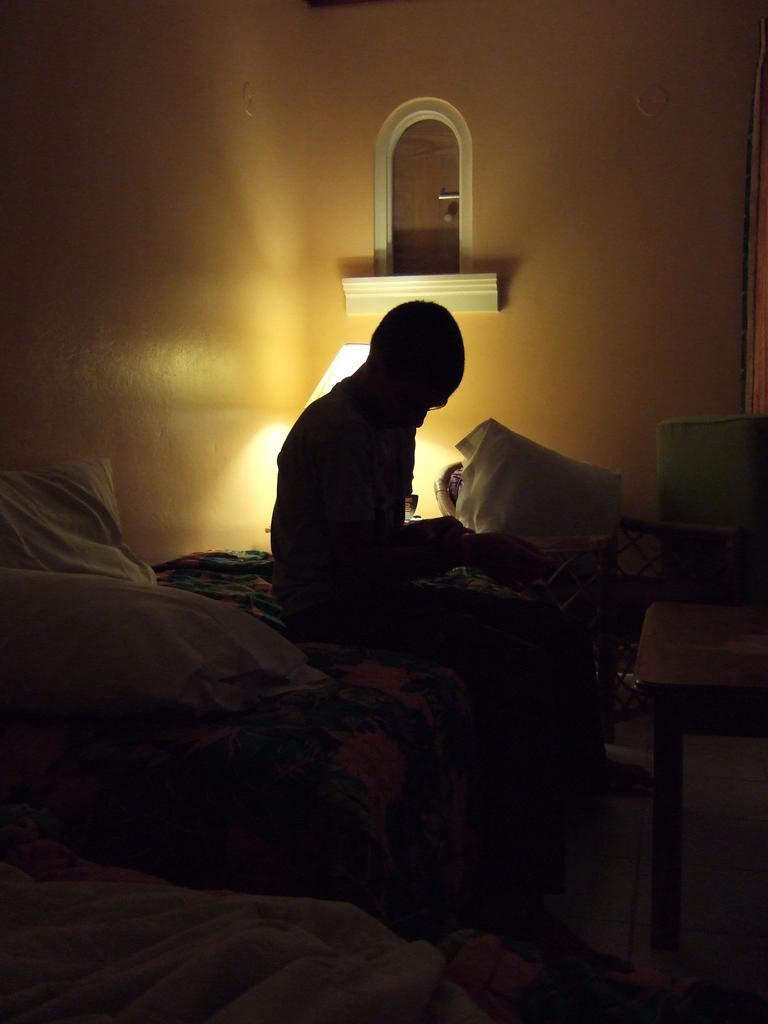In one or two sentences, can you explain what this image depicts? This picture is taken in the dark where we can see a person is sitting on the bed, here we can see pillows, table, table lamp and the mirror is fixed to the wall. 